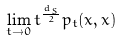<formula> <loc_0><loc_0><loc_500><loc_500>\lim _ { t \to 0 } t ^ { \frac { d _ { S } } 2 } p _ { t } ( x , x )</formula> 